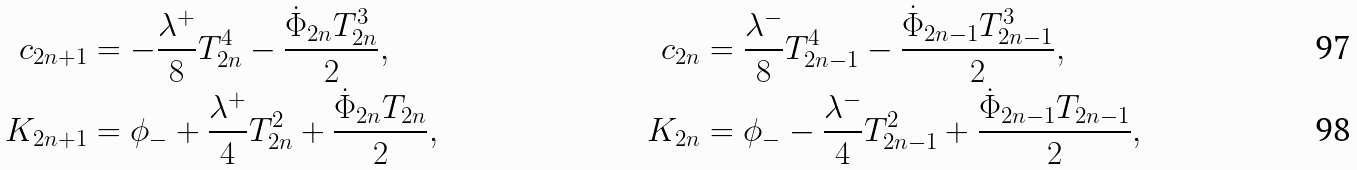Convert formula to latex. <formula><loc_0><loc_0><loc_500><loc_500>c _ { 2 n + 1 } & = - \frac { \lambda ^ { + } } { 8 } T _ { 2 n } ^ { 4 } - \frac { { \dot { \Phi } _ { 2 n } T _ { 2 n } ^ { 3 } } } { 2 } , & c _ { 2 n } & = \frac { \lambda ^ { - } } { 8 } T _ { 2 n - 1 } ^ { 4 } - \frac { { \dot { \Phi } _ { 2 n - 1 } T _ { 2 n - 1 } ^ { 3 } } } { 2 } , \\ K _ { 2 n + 1 } & = \phi _ { - } + \frac { \lambda ^ { + } } { 4 } T _ { 2 n } ^ { 2 } + \frac { { \dot { \Phi } _ { 2 n } T _ { 2 n } } } { 2 } , & K _ { 2 n } & = \phi _ { - } - \frac { \lambda ^ { - } } { 4 } T _ { 2 n - 1 } ^ { 2 } + \frac { { \dot { \Phi } _ { 2 n - 1 } T _ { 2 n - 1 } } } { 2 } ,</formula> 